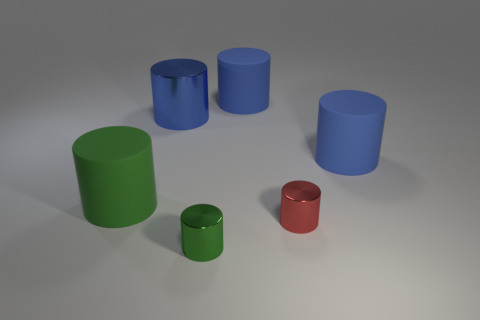Subtract all blue cylinders. How many were subtracted if there are1blue cylinders left? 2 Subtract all yellow spheres. How many green cylinders are left? 2 Subtract all small red metal cylinders. How many cylinders are left? 5 Subtract all green cylinders. How many cylinders are left? 4 Add 2 blue matte things. How many objects exist? 8 Subtract all purple cylinders. Subtract all purple cubes. How many cylinders are left? 6 Add 3 small red objects. How many small red objects are left? 4 Add 6 small brown balls. How many small brown balls exist? 6 Subtract 0 brown balls. How many objects are left? 6 Subtract all blue rubber cylinders. Subtract all blue objects. How many objects are left? 1 